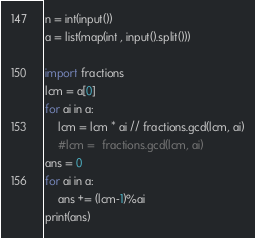Convert code to text. <code><loc_0><loc_0><loc_500><loc_500><_Python_>n = int(input())
a = list(map(int , input().split()))

import fractions
lcm = a[0]
for ai in a:
    lcm = lcm * ai // fractions.gcd(lcm, ai)
    #lcm =  fractions.gcd(lcm, ai)
ans = 0
for ai in a:
    ans += (lcm-1)%ai
print(ans)
</code> 